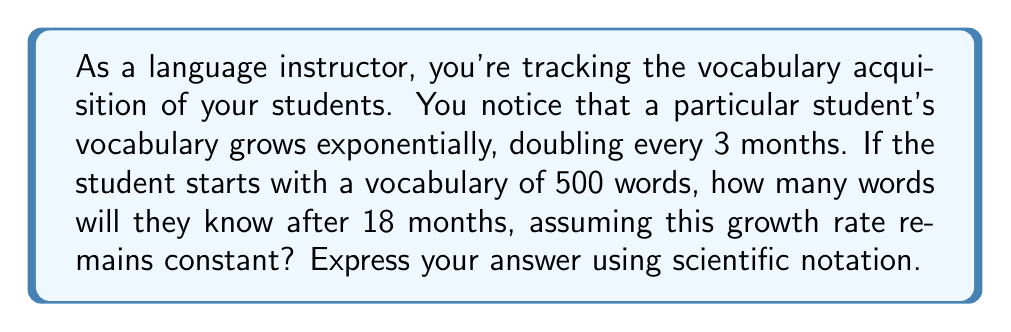What is the answer to this math problem? To solve this problem, we'll use the exponential growth formula:

$$A = P(1 + r)^t$$

Where:
$A$ = Final amount
$P$ = Initial amount (500 words)
$r$ = Growth rate per unit time
$t$ = Number of time units

First, we need to determine the growth rate $r$. We know the vocabulary doubles every 3 months, so:

$$500 \cdot (1 + r)^3 = 1000$$

Solving for $r$:

$$(1 + r)^3 = 2$$
$$1 + r = 2^{\frac{1}{3}}$$
$$r = 2^{\frac{1}{3}} - 1 \approx 0.2599$$

Now, we can use this rate in our original formula. The time $t$ is 18 months, which is 6 three-month periods:

$$A = 500(1 + 0.2599)^6$$

Using a calculator:

$$A = 500 \cdot (1.2599)^6 \approx 500 \cdot 3.9837 \approx 1991.85$$

Rounding to the nearest whole number and expressing in scientific notation:

$$A \approx 1.99 \cdot 10^3 \text{ words}$$
Answer: $1.99 \cdot 10^3$ words 